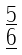<formula> <loc_0><loc_0><loc_500><loc_500>\begin{smallmatrix} \underline { 5 } \\ \underline { 6 } \end{smallmatrix}</formula> 